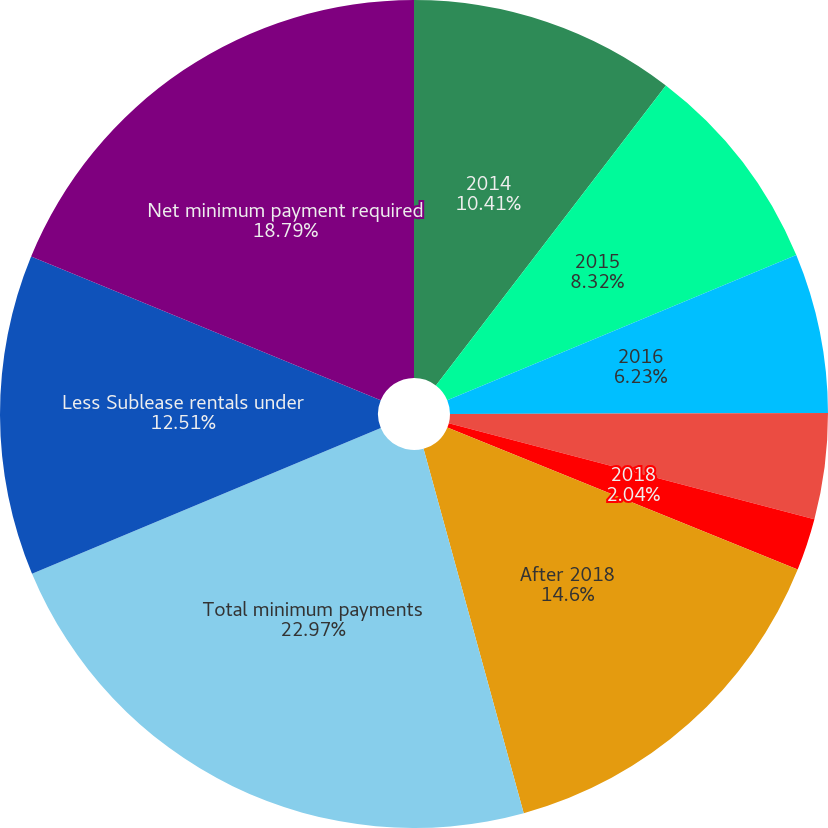<chart> <loc_0><loc_0><loc_500><loc_500><pie_chart><fcel>2014<fcel>2015<fcel>2016<fcel>2017<fcel>2018<fcel>After 2018<fcel>Total minimum payments<fcel>Less Sublease rentals under<fcel>Net minimum payment required<nl><fcel>10.41%<fcel>8.32%<fcel>6.23%<fcel>4.13%<fcel>2.04%<fcel>14.6%<fcel>22.97%<fcel>12.51%<fcel>18.79%<nl></chart> 